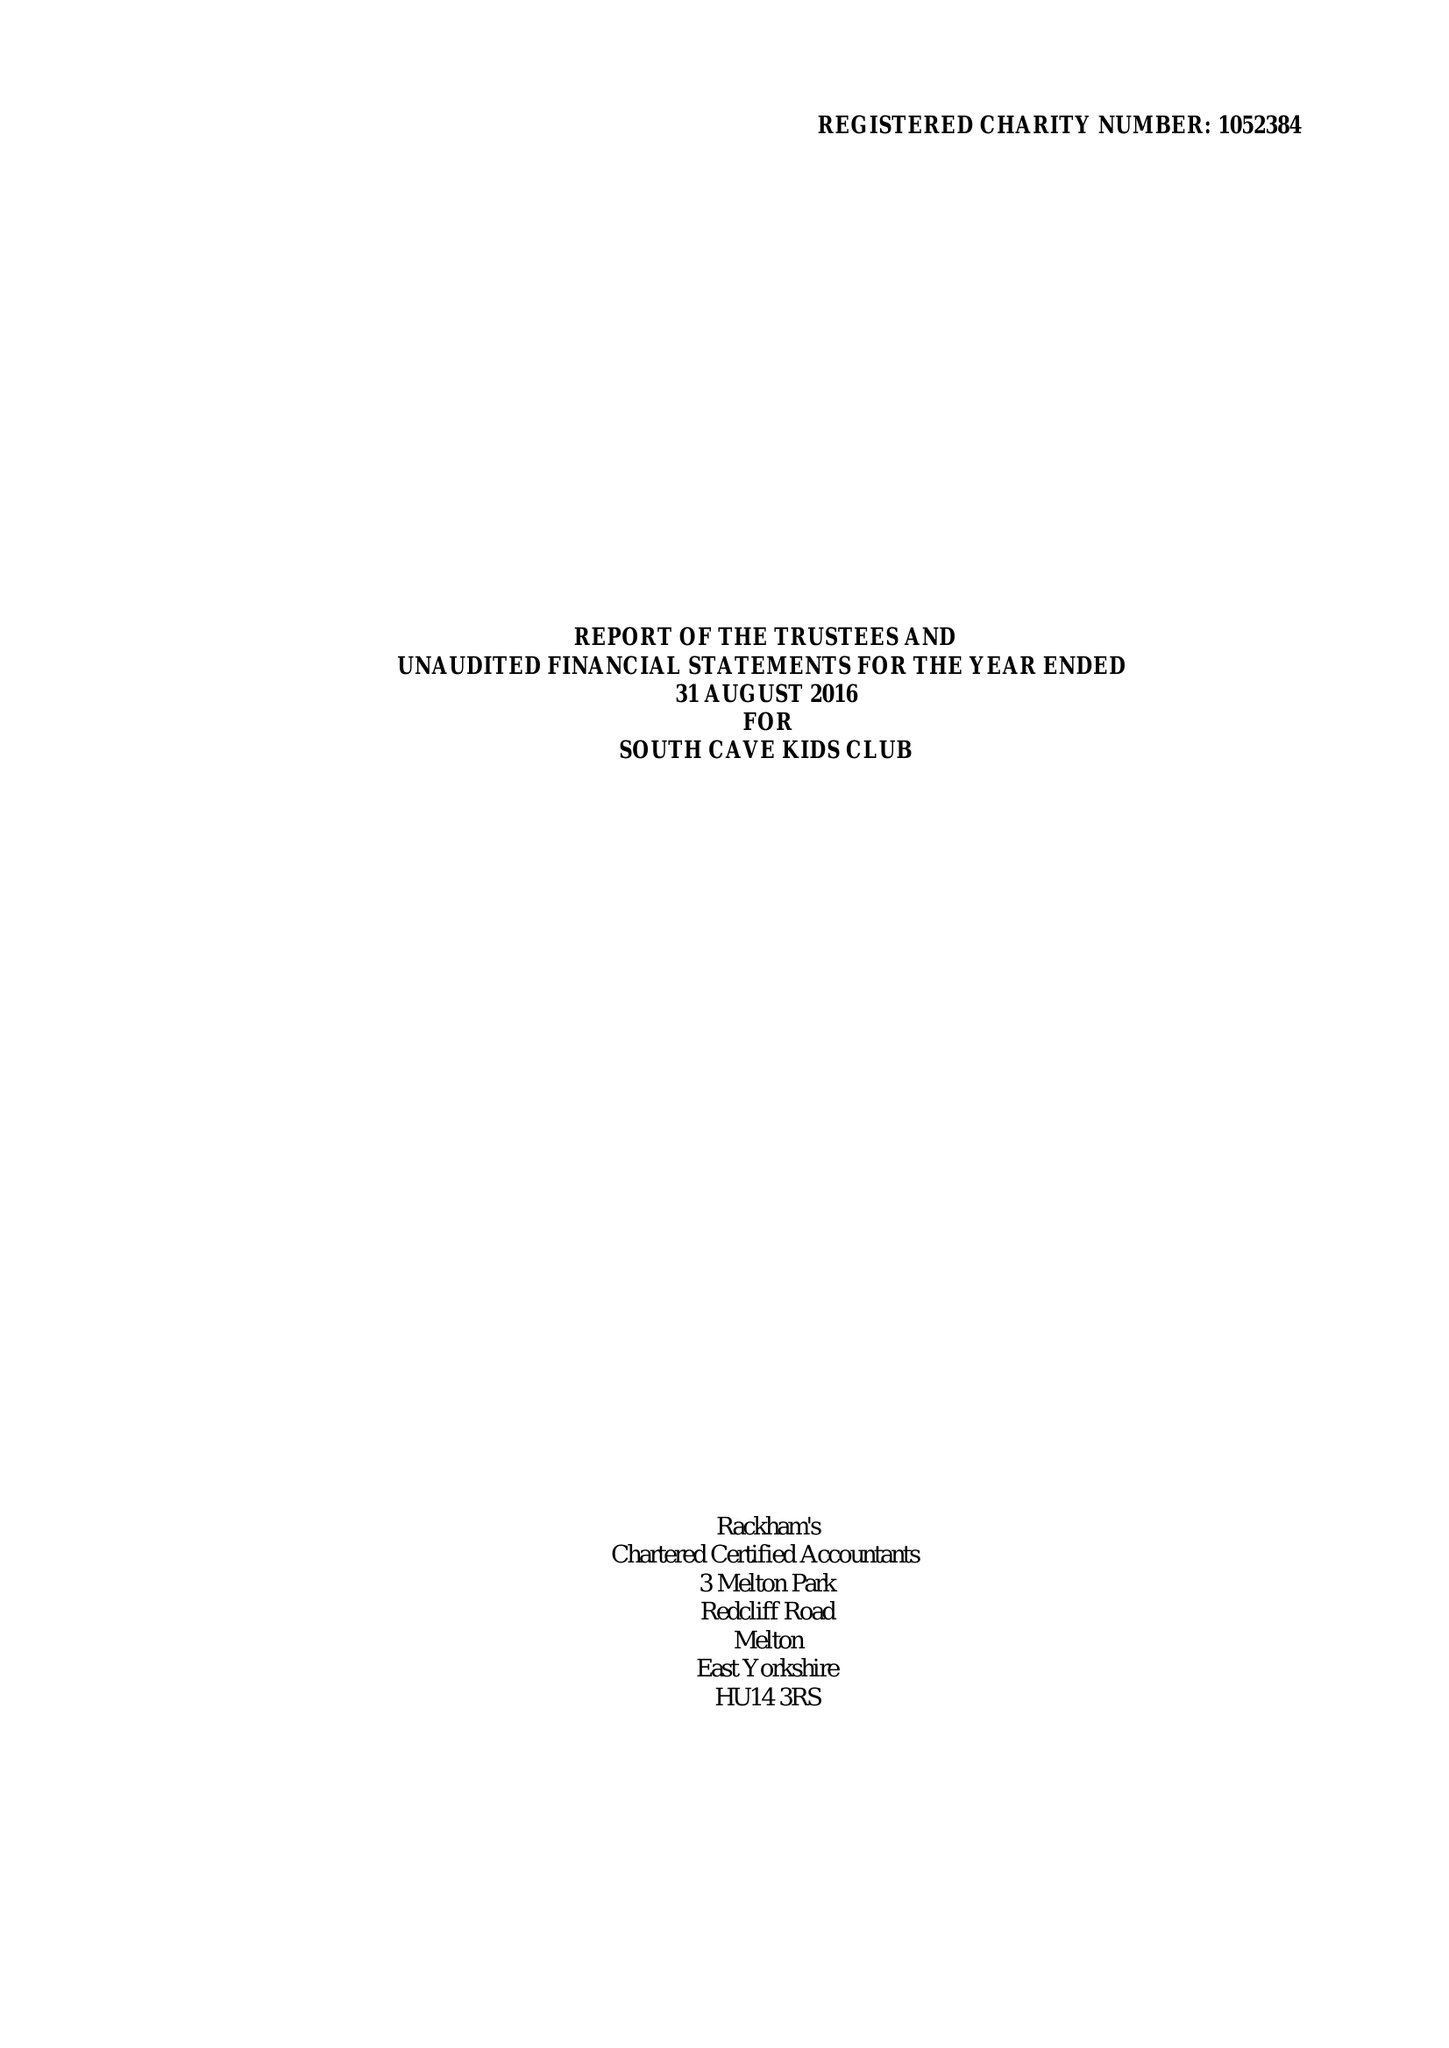What is the value for the income_annually_in_british_pounds?
Answer the question using a single word or phrase. 142350.00 